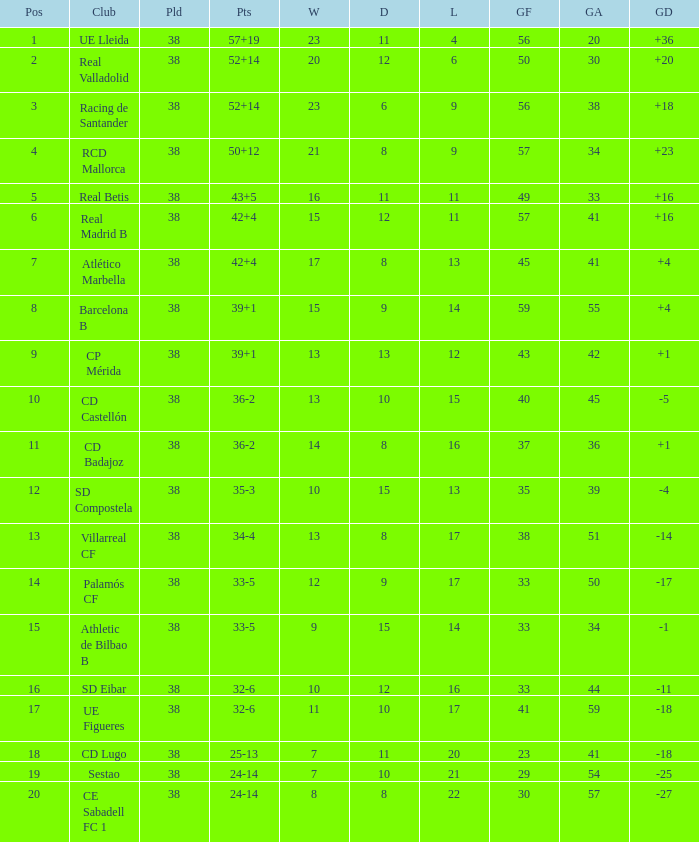What is the highest number played with a goal difference less than -27? None. 